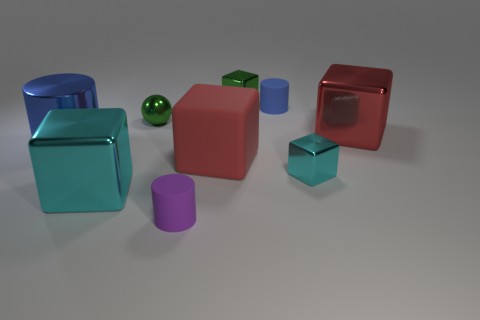How many objects are either metallic objects that are left of the tiny purple cylinder or shiny objects that are on the right side of the green cube?
Ensure brevity in your answer.  5. Does the red metal thing have the same size as the red block in front of the large blue metal object?
Offer a very short reply. Yes. Do the red thing that is to the right of the small cyan metal object and the big red cube that is left of the tiny cyan thing have the same material?
Your answer should be compact. No. Are there an equal number of tiny green metal balls to the right of the green block and tiny metallic spheres that are behind the blue rubber thing?
Your answer should be very brief. Yes. How many objects are the same color as the large cylinder?
Provide a succinct answer. 1. What material is the thing that is the same color as the big cylinder?
Offer a very short reply. Rubber. How many rubber objects are cubes or green things?
Your answer should be very brief. 1. There is a blue thing in front of the tiny blue cylinder; does it have the same shape as the blue thing that is on the right side of the big cyan shiny thing?
Your response must be concise. Yes. What number of green metal balls are behind the tiny green metal sphere?
Offer a very short reply. 0. Are there any gray cylinders that have the same material as the small purple object?
Provide a succinct answer. No. 